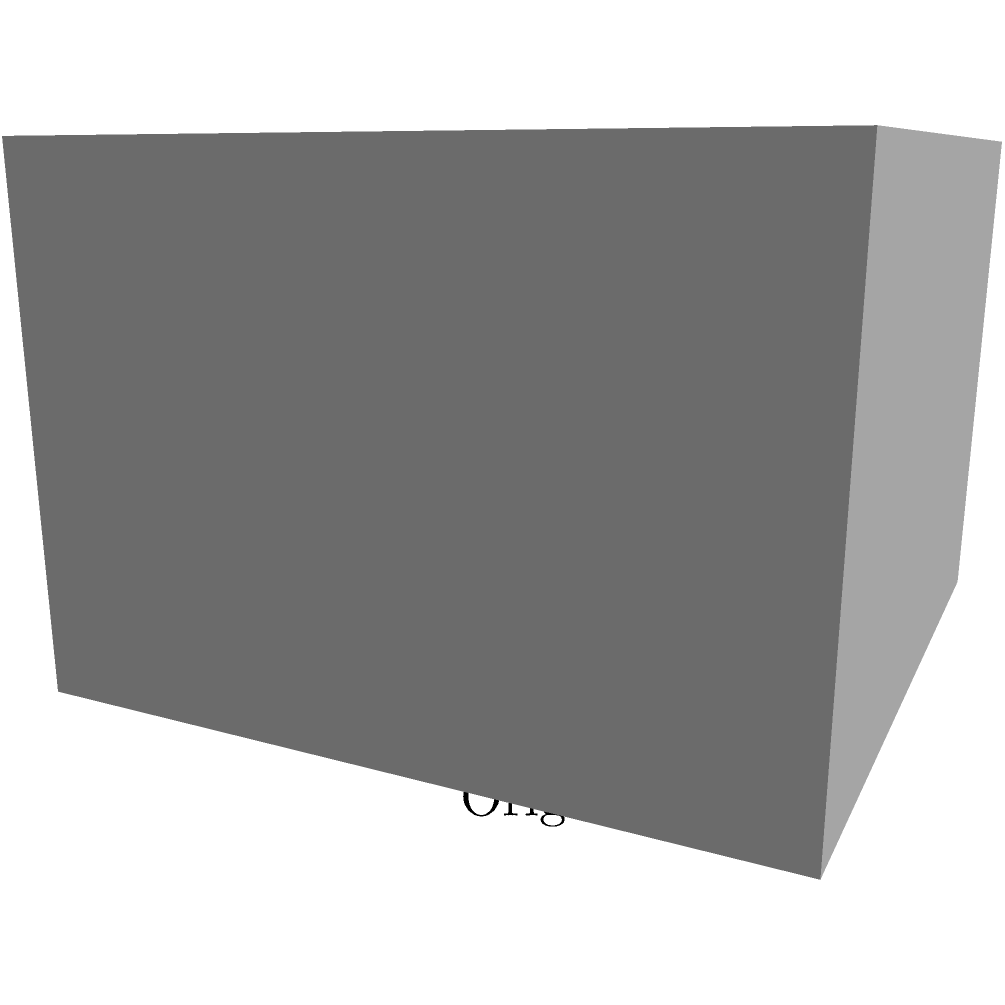In the context of optimizing 3D models for game performance, what is the primary benefit of applying mesh simplification techniques, as illustrated in the transition from the left cube to the right cube? To understand the benefits of mesh simplification, let's break down the process and its effects:

1. Polygon count reduction: The original cube (left) is composed of 12 triangles (2 per face), while the simplified version (right) uses only 12 edges to represent the same shape.

2. Vertex count reduction: The original cube has 8 vertices, while the simplified version maintains the same overall shape with only 8 vertices as well, but represents them more efficiently.

3. Performance improvement: Fewer polygons and vertices mean less data for the GPU to process, resulting in:
   a) Faster rendering times
   b) Reduced memory usage
   c) Improved frame rates, especially when dealing with multiple objects

4. Scalability: This technique allows for creating level-of-detail (LOD) models, where simpler versions are used for distant objects, further optimizing performance.

5. Bandwidth efficiency: Simplified models require less data to be transferred, which is crucial for networked games or streaming assets.

6. Resource management: Smaller model sizes allow for more efficient use of memory and storage, which is particularly important for mobile games or platforms with limited resources.

The primary benefit, therefore, is the significant performance improvement achieved by reducing the computational load on the GPU while maintaining the overall visual representation of the object.
Answer: Improved performance through reduced polygon count and computational load 